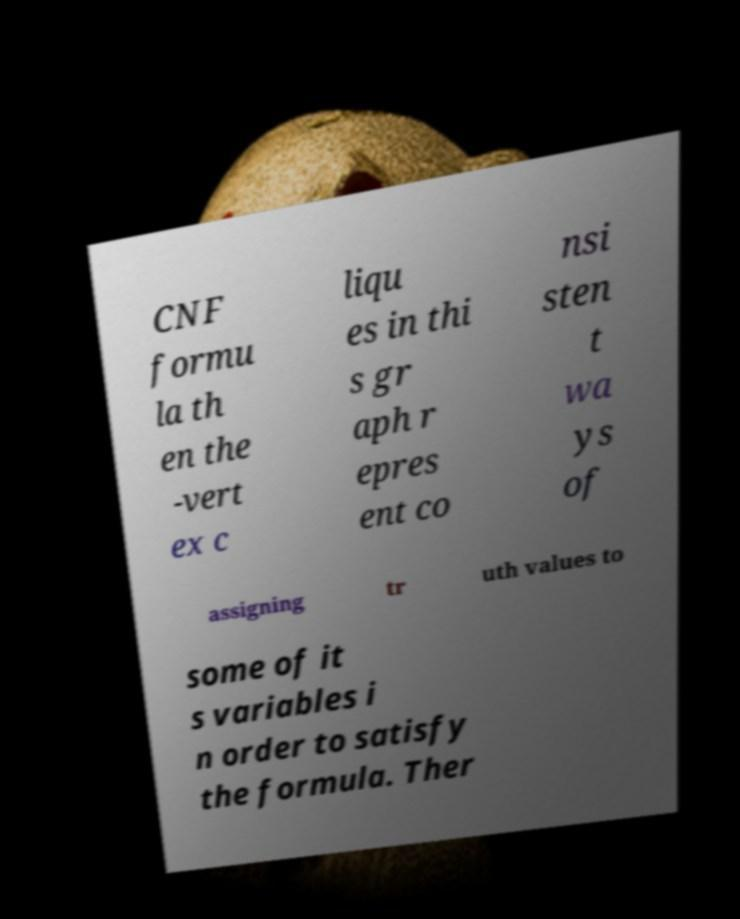Could you extract and type out the text from this image? CNF formu la th en the -vert ex c liqu es in thi s gr aph r epres ent co nsi sten t wa ys of assigning tr uth values to some of it s variables i n order to satisfy the formula. Ther 